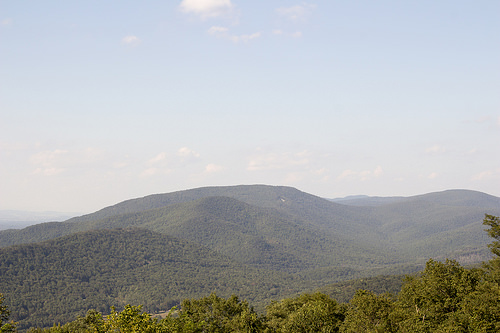<image>
Is there a plant under the sky? Yes. The plant is positioned underneath the sky, with the sky above it in the vertical space. 